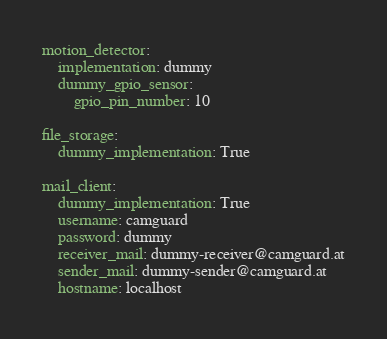<code> <loc_0><loc_0><loc_500><loc_500><_YAML_>motion_detector:
    implementation: dummy
    dummy_gpio_sensor: 
        gpio_pin_number: 10

file_storage:
    dummy_implementation: True

mail_client:
    dummy_implementation: True
    username: camguard 
    password: dummy
    receiver_mail: dummy-receiver@camguard.at
    sender_mail: dummy-sender@camguard.at
    hostname: localhost


</code> 